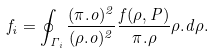<formula> <loc_0><loc_0><loc_500><loc_500>f _ { i } = \oint _ { \Gamma _ { i } } \frac { ( \pi . o ) ^ { 2 } } { ( \rho . o ) ^ { 2 } } \frac { f ( \rho , P ) } { \pi . \rho } \rho . d \rho .</formula> 